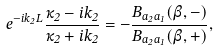<formula> <loc_0><loc_0><loc_500><loc_500>e ^ { - i k _ { 2 } L } \frac { \kappa _ { 2 } - i k _ { 2 } } { \kappa _ { 2 } + i k _ { 2 } } = - \frac { B _ { a _ { 2 } a _ { 1 } } ( \beta , - ) } { B _ { a _ { 2 } a _ { 1 } } ( \beta , + ) } ,</formula> 